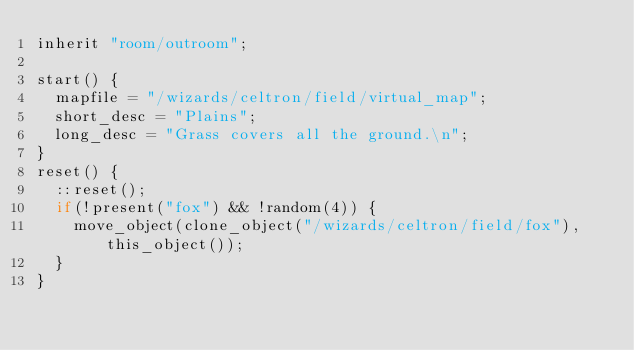Convert code to text. <code><loc_0><loc_0><loc_500><loc_500><_C_>inherit "room/outroom";

start() {
  mapfile = "/wizards/celtron/field/virtual_map";
  short_desc = "Plains";
  long_desc = "Grass covers all the ground.\n";
}
reset() {
  ::reset();
  if(!present("fox") && !random(4)) {
    move_object(clone_object("/wizards/celtron/field/fox"), this_object());
  }
}

</code> 